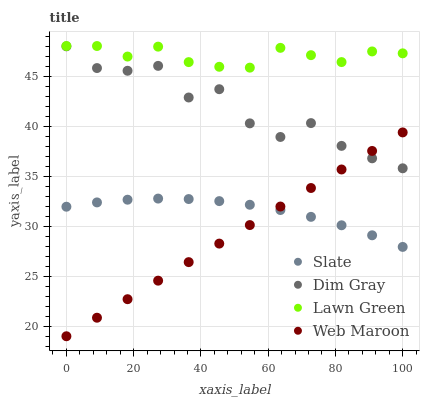Does Web Maroon have the minimum area under the curve?
Answer yes or no. Yes. Does Lawn Green have the maximum area under the curve?
Answer yes or no. Yes. Does Slate have the minimum area under the curve?
Answer yes or no. No. Does Slate have the maximum area under the curve?
Answer yes or no. No. Is Web Maroon the smoothest?
Answer yes or no. Yes. Is Dim Gray the roughest?
Answer yes or no. Yes. Is Slate the smoothest?
Answer yes or no. No. Is Slate the roughest?
Answer yes or no. No. Does Web Maroon have the lowest value?
Answer yes or no. Yes. Does Slate have the lowest value?
Answer yes or no. No. Does Lawn Green have the highest value?
Answer yes or no. Yes. Does Dim Gray have the highest value?
Answer yes or no. No. Is Slate less than Dim Gray?
Answer yes or no. Yes. Is Lawn Green greater than Web Maroon?
Answer yes or no. Yes. Does Web Maroon intersect Slate?
Answer yes or no. Yes. Is Web Maroon less than Slate?
Answer yes or no. No. Is Web Maroon greater than Slate?
Answer yes or no. No. Does Slate intersect Dim Gray?
Answer yes or no. No. 